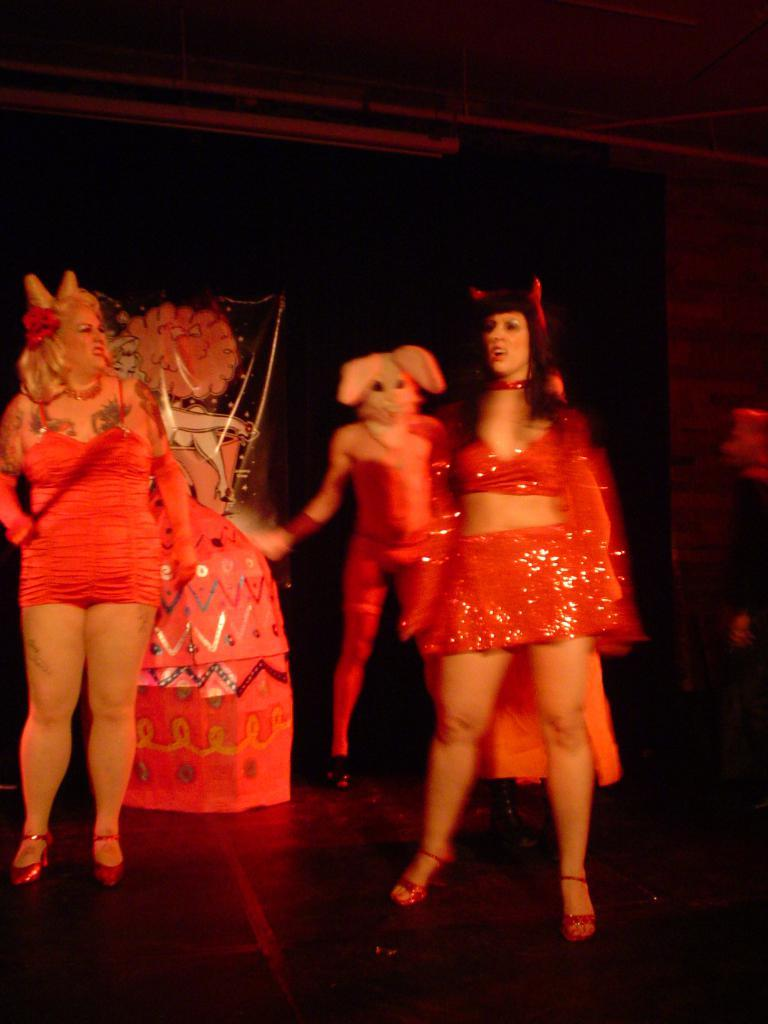What is happening in the image? There are people standing in the image. Where are the people located? The people are on the floor. What are the people wearing? The people are wearing costumes. What can be observed about the background of the image? The background of the image is dark. What type of smell can be detected in the image? There is no information about smells in the image, so it cannot be determined from the image. 